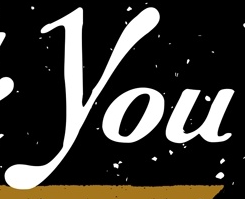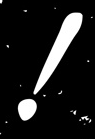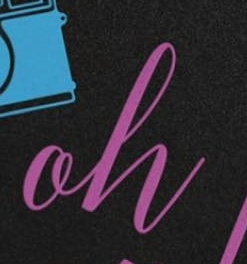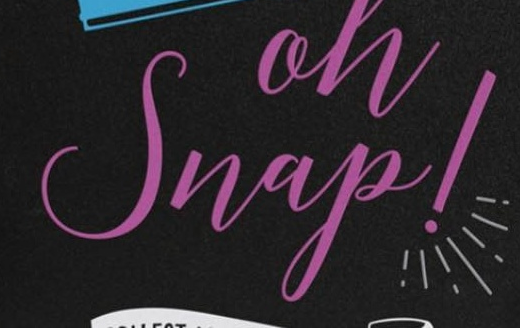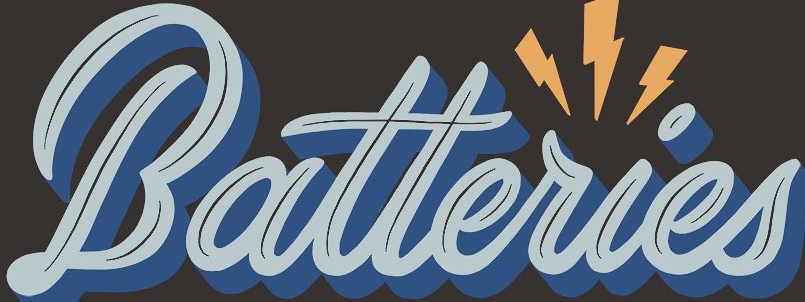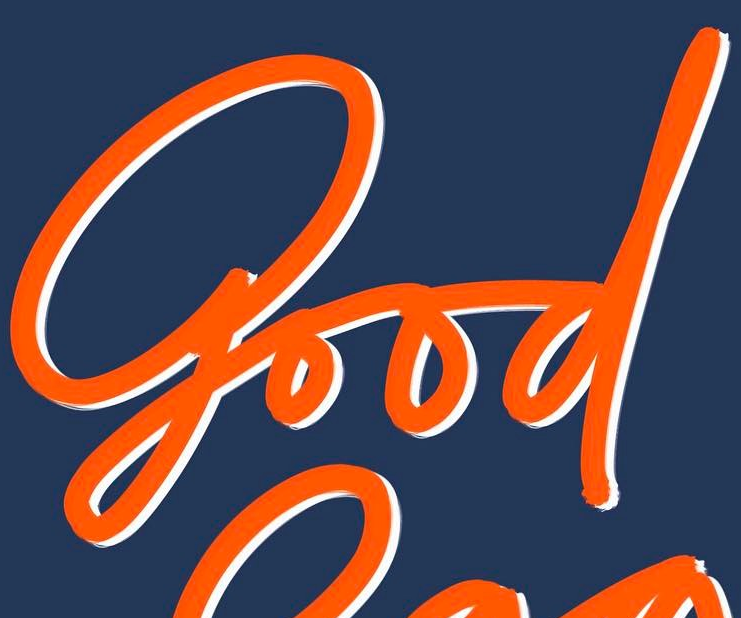Read the text content from these images in order, separated by a semicolon. You; !; oh; Snap!; Batteries; good 